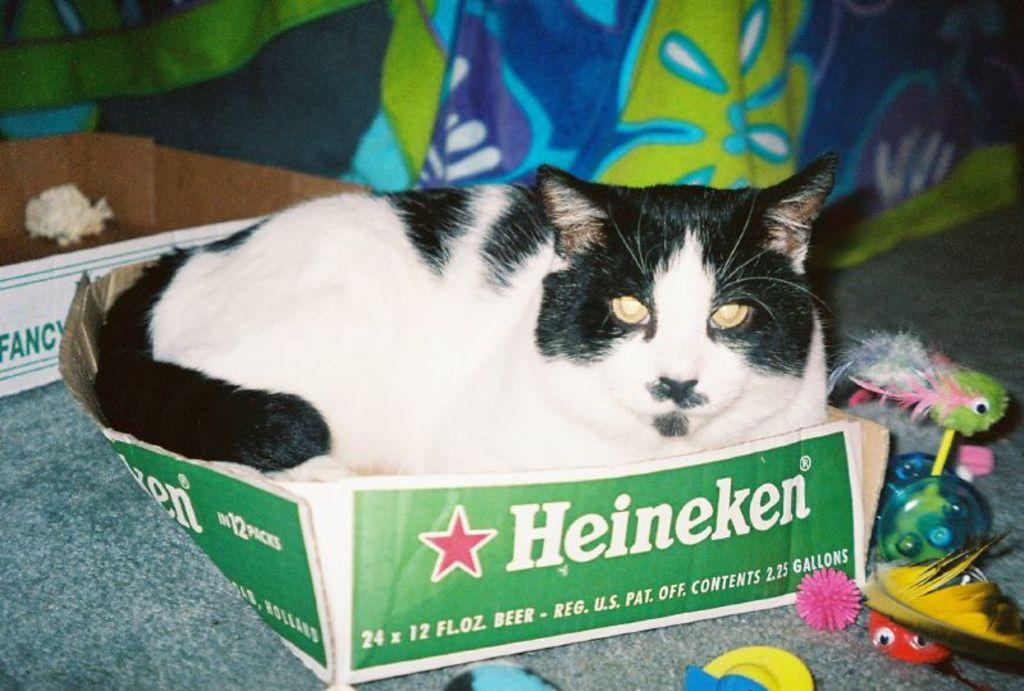<image>
Describe the image concisely. A black and white cat sitting inside of a box made for Heineken beers. 